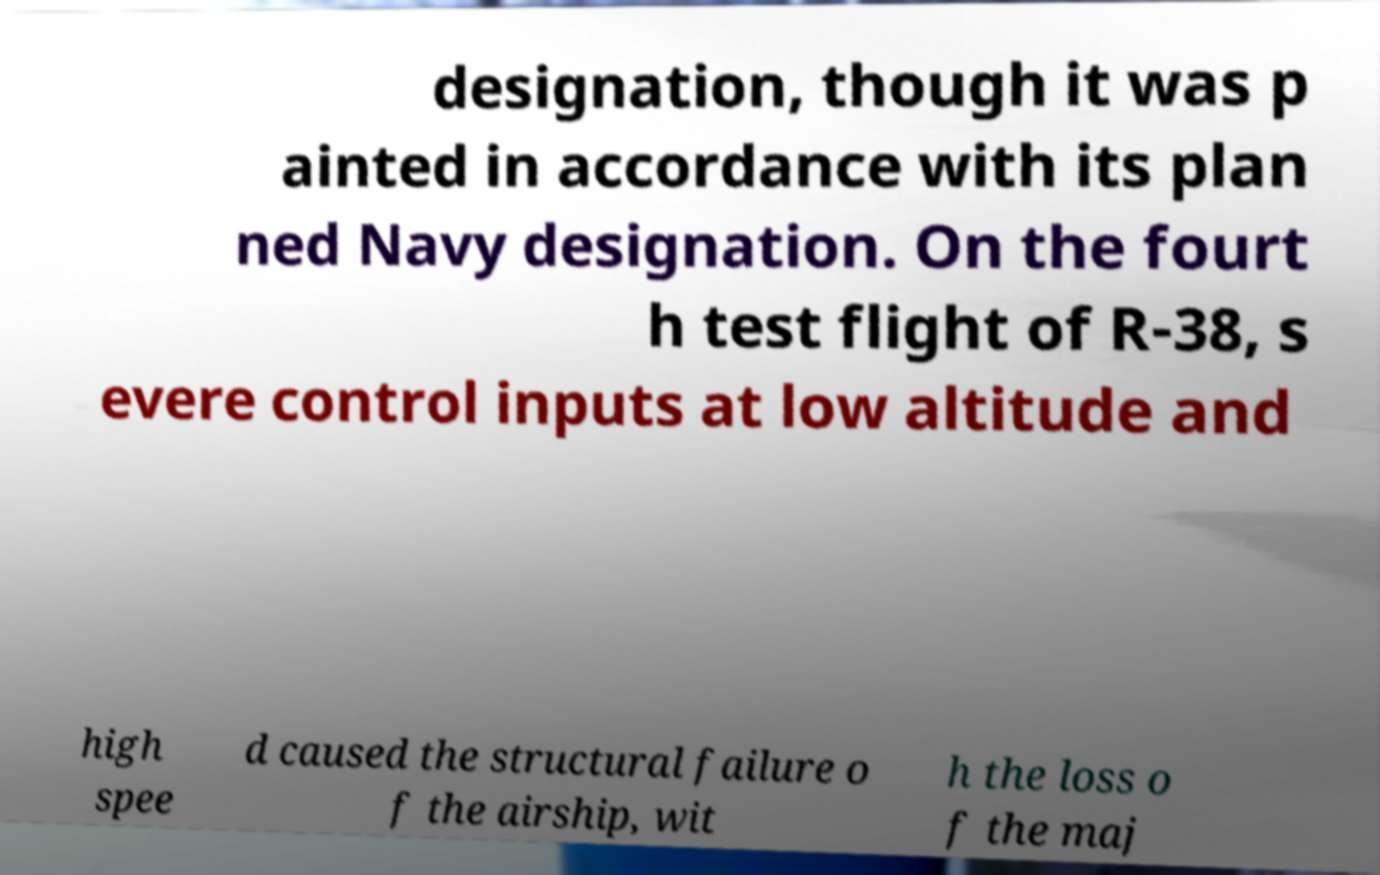Could you extract and type out the text from this image? designation, though it was p ainted in accordance with its plan ned Navy designation. On the fourt h test flight of R-38, s evere control inputs at low altitude and high spee d caused the structural failure o f the airship, wit h the loss o f the maj 